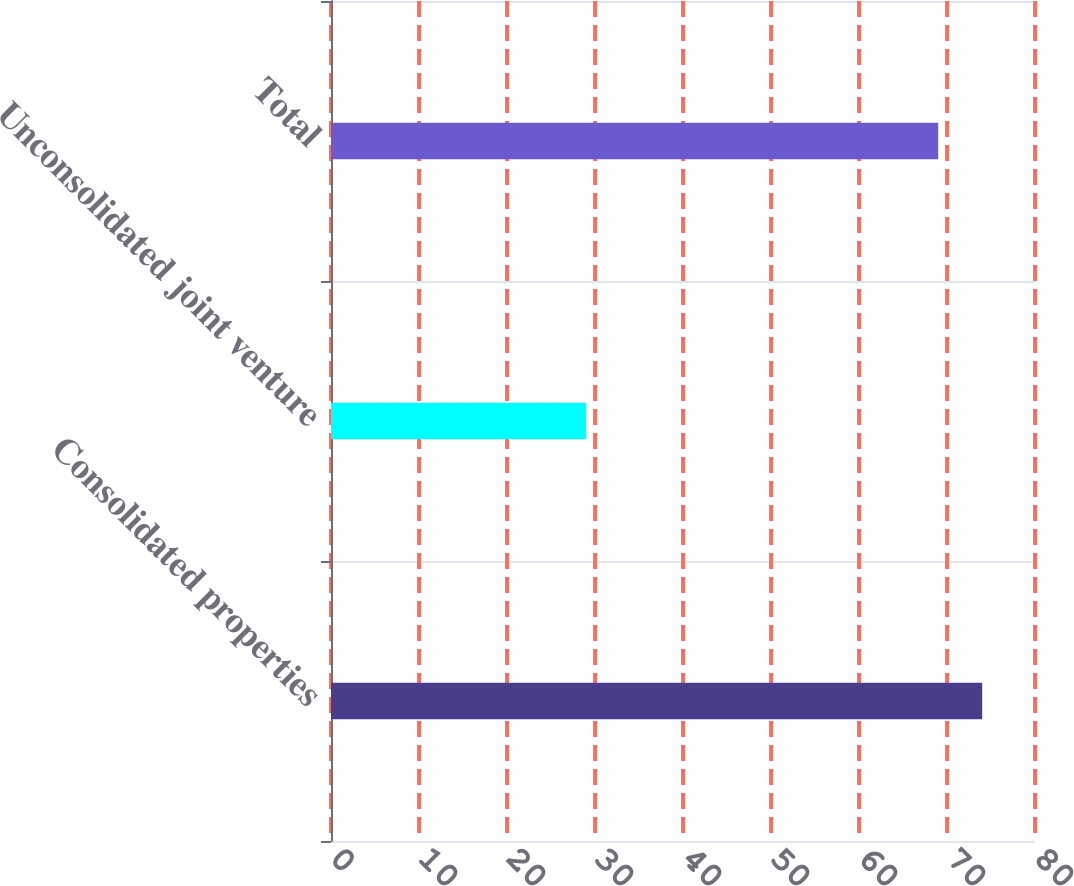Convert chart. <chart><loc_0><loc_0><loc_500><loc_500><bar_chart><fcel>Consolidated properties<fcel>Unconsolidated joint venture<fcel>Total<nl><fcel>74<fcel>29<fcel>69<nl></chart> 